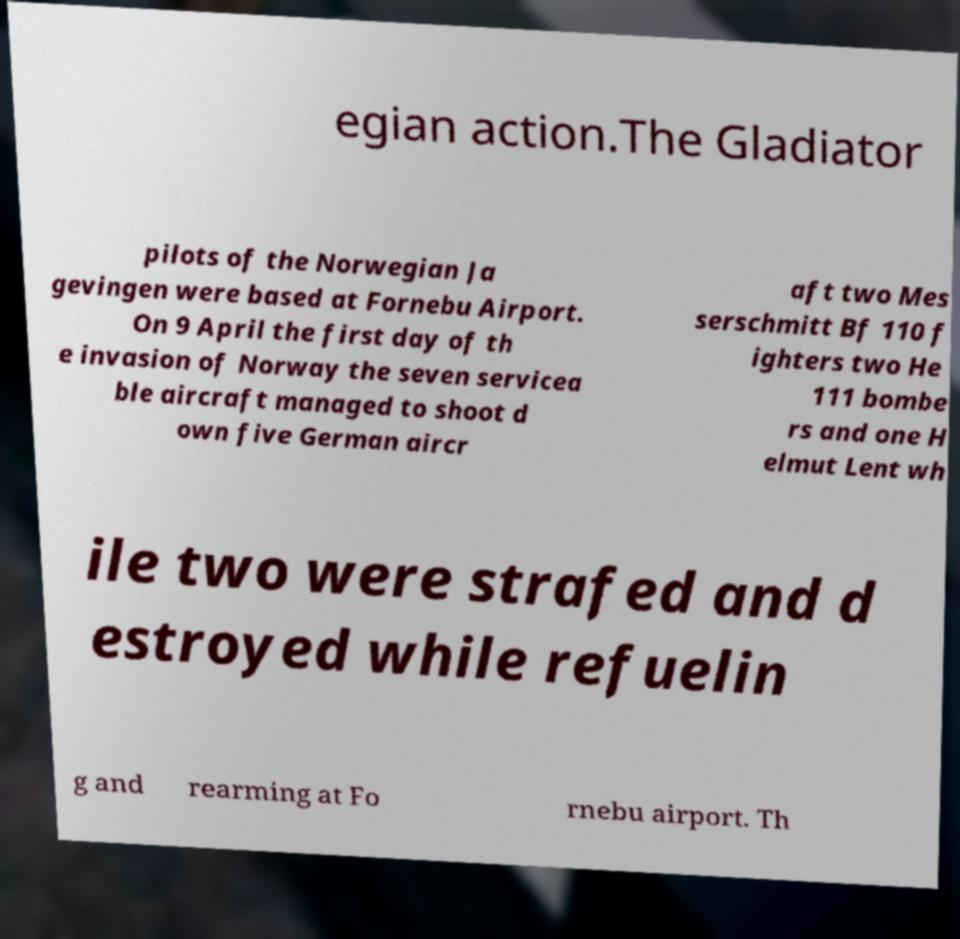There's text embedded in this image that I need extracted. Can you transcribe it verbatim? egian action.The Gladiator pilots of the Norwegian Ja gevingen were based at Fornebu Airport. On 9 April the first day of th e invasion of Norway the seven servicea ble aircraft managed to shoot d own five German aircr aft two Mes serschmitt Bf 110 f ighters two He 111 bombe rs and one H elmut Lent wh ile two were strafed and d estroyed while refuelin g and rearming at Fo rnebu airport. Th 